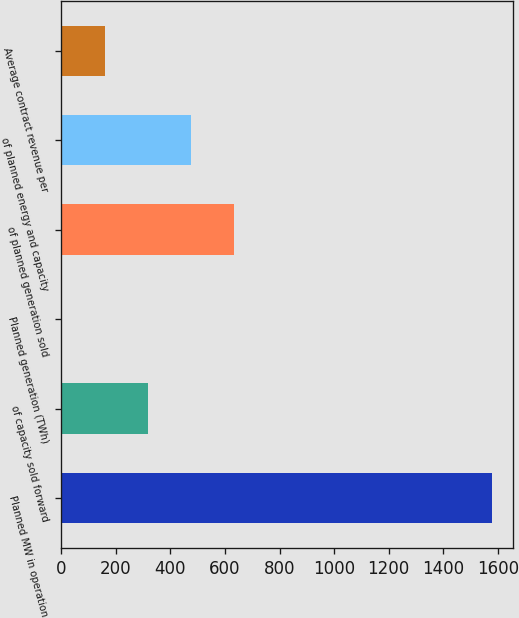Convert chart. <chart><loc_0><loc_0><loc_500><loc_500><bar_chart><fcel>Planned MW in operation<fcel>of capacity sold forward<fcel>Planned generation (TWh)<fcel>of planned generation sold<fcel>of planned energy and capacity<fcel>Average contract revenue per<nl><fcel>1578<fcel>318<fcel>3<fcel>633<fcel>475.5<fcel>160.5<nl></chart> 